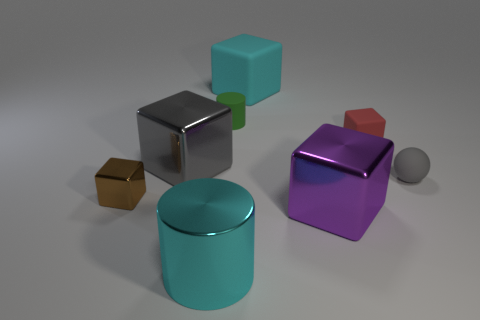Subtract all purple blocks. How many blocks are left? 4 Subtract all big rubber blocks. How many blocks are left? 4 Add 1 metallic objects. How many objects exist? 9 Subtract all green cubes. Subtract all green cylinders. How many cubes are left? 5 Subtract all cubes. How many objects are left? 3 Add 1 purple rubber blocks. How many purple rubber blocks exist? 1 Subtract 1 brown cubes. How many objects are left? 7 Subtract all large shiny cylinders. Subtract all cyan rubber blocks. How many objects are left? 6 Add 5 small green cylinders. How many small green cylinders are left? 6 